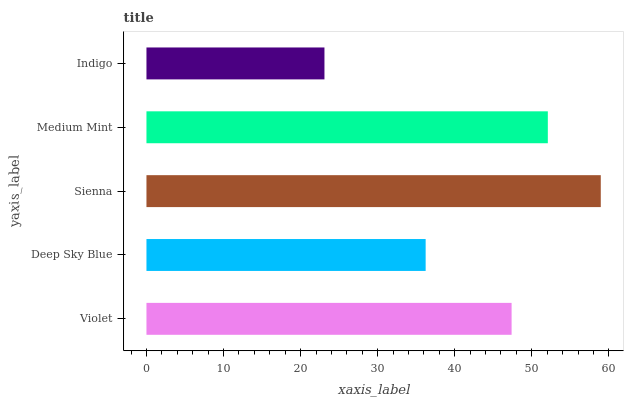Is Indigo the minimum?
Answer yes or no. Yes. Is Sienna the maximum?
Answer yes or no. Yes. Is Deep Sky Blue the minimum?
Answer yes or no. No. Is Deep Sky Blue the maximum?
Answer yes or no. No. Is Violet greater than Deep Sky Blue?
Answer yes or no. Yes. Is Deep Sky Blue less than Violet?
Answer yes or no. Yes. Is Deep Sky Blue greater than Violet?
Answer yes or no. No. Is Violet less than Deep Sky Blue?
Answer yes or no. No. Is Violet the high median?
Answer yes or no. Yes. Is Violet the low median?
Answer yes or no. Yes. Is Medium Mint the high median?
Answer yes or no. No. Is Indigo the low median?
Answer yes or no. No. 